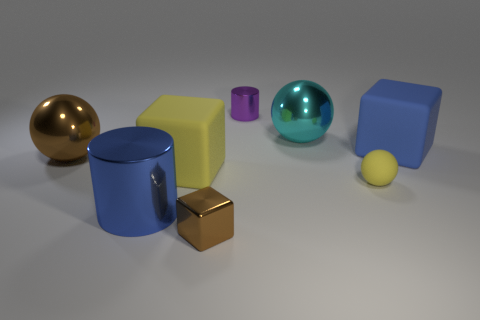How big is the metal thing that is in front of the big cyan object and behind the blue metal cylinder?
Your response must be concise. Large. There is a small yellow thing; is its shape the same as the big metallic thing behind the big brown ball?
Make the answer very short. Yes. How many objects are shiny things to the right of the large brown thing or purple metallic cylinders?
Offer a very short reply. 4. Does the big blue cylinder have the same material as the cube that is on the right side of the tiny brown cube?
Offer a terse response. No. There is a small object that is behind the rubber block to the right of the small metal cylinder; what shape is it?
Give a very brief answer. Cylinder. There is a tiny rubber object; is its color the same as the large matte thing in front of the large blue rubber block?
Ensure brevity in your answer.  Yes. What is the shape of the purple metallic thing?
Your response must be concise. Cylinder. There is a metal sphere that is behind the large blue thing that is to the right of the purple shiny thing; what size is it?
Make the answer very short. Large. Are there an equal number of yellow spheres that are to the right of the big brown metal sphere and brown objects that are to the right of the small purple shiny cylinder?
Provide a succinct answer. No. What is the material of the tiny thing that is both in front of the big cyan shiny ball and to the left of the large cyan ball?
Provide a succinct answer. Metal. 